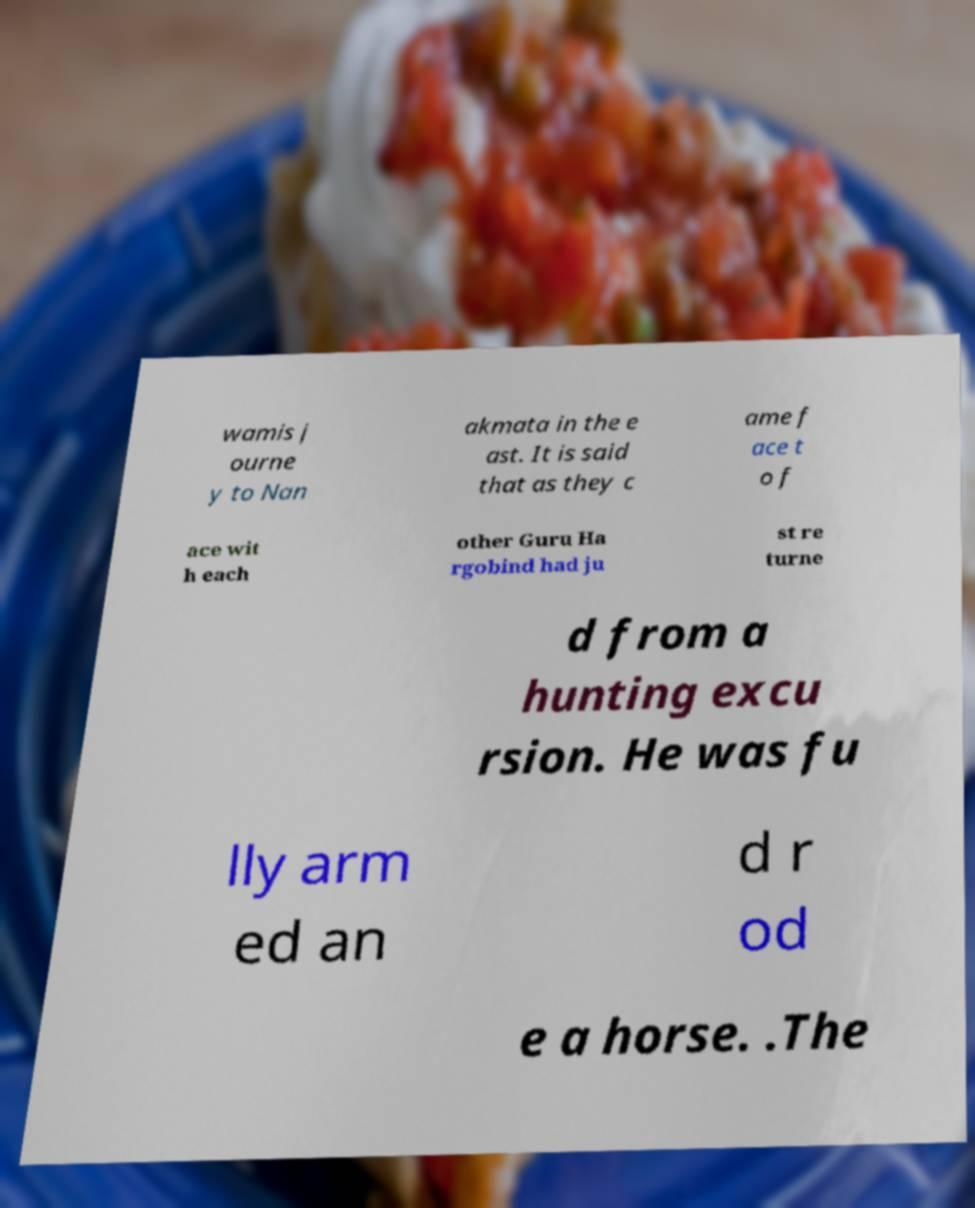Could you extract and type out the text from this image? wamis j ourne y to Nan akmata in the e ast. It is said that as they c ame f ace t o f ace wit h each other Guru Ha rgobind had ju st re turne d from a hunting excu rsion. He was fu lly arm ed an d r od e a horse. .The 